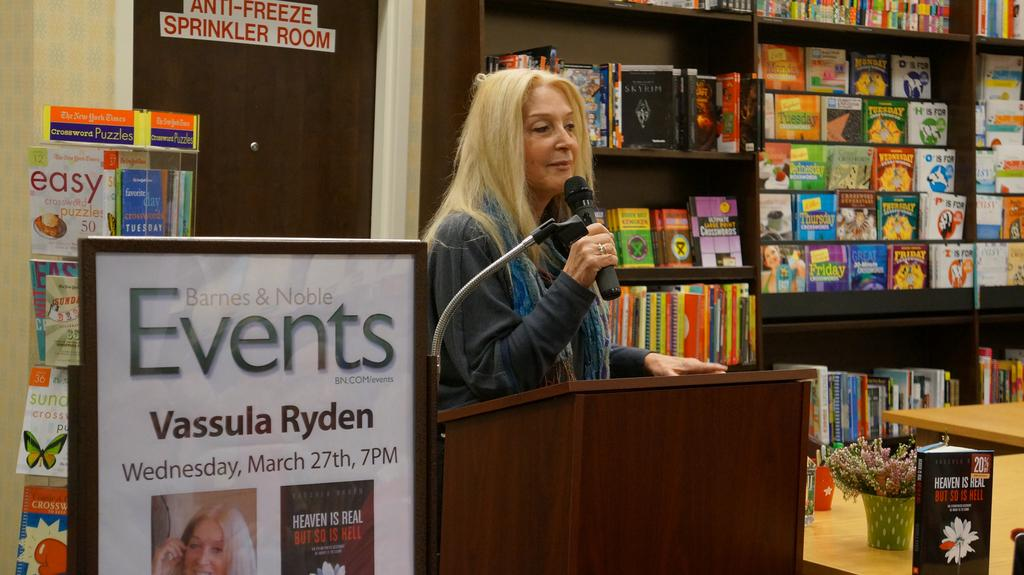Provide a one-sentence caption for the provided image. A woman next to a poster for Vassula Ryden. 